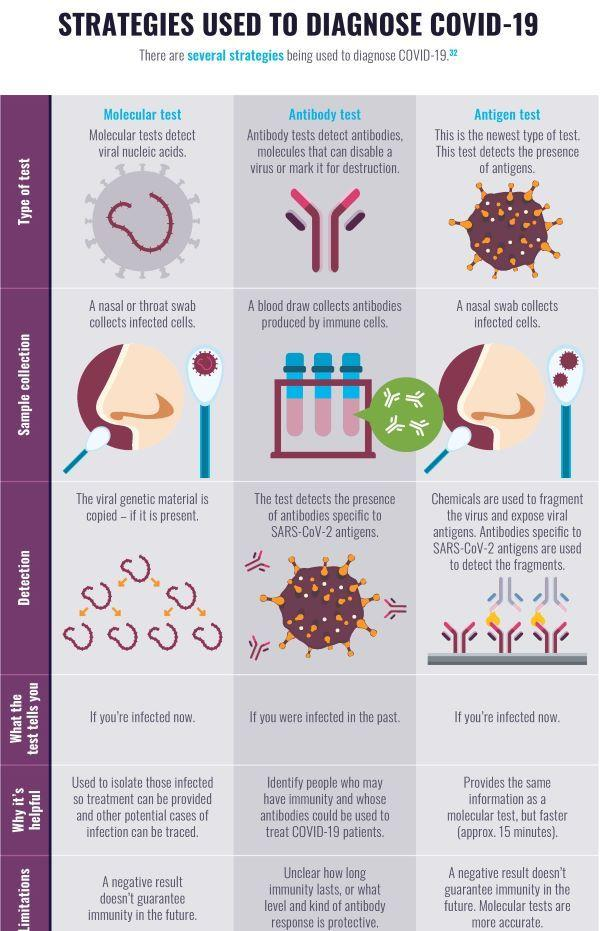Give some essential details in this illustration. The antibody test is a diagnostic tool that can identify individuals who have recovered from COVID-19 without experiencing any significant health issues. The nasal swab can only be used for antigen testing, which is a specific type of corona virus test. The antibody test confirms that a person who has been tested was infected with the coronavirus at some point in time. The antigen test is the coronavirus test that provides a more precise result. The collection of a nasal or throat swab is taken for molecular and antigen tests to determine the presence of the COVID-19 coronavirus in individuals, as part of a comprehensive diagnostic procedure. 